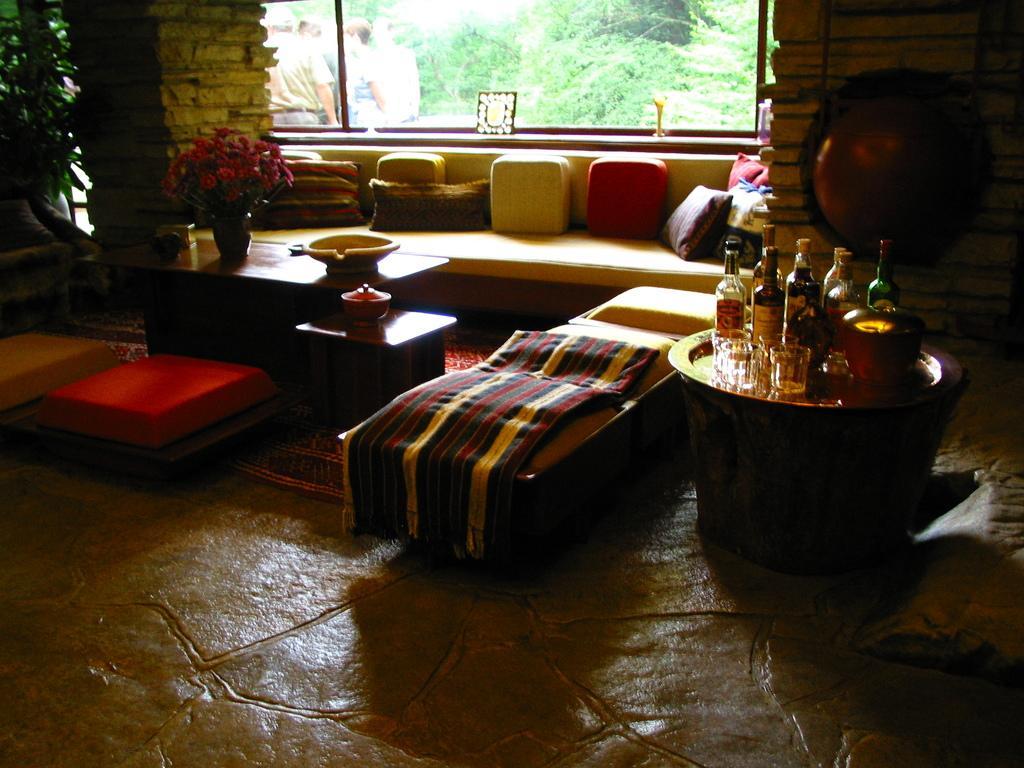How would you summarize this image in a sentence or two? In this room we can able to see couch with pillows, bed with bed-sheet and floor with carpet. On this tablet there is a flower vase, bowl, glasses and bottles. From this window we can able to see persons and trees. 